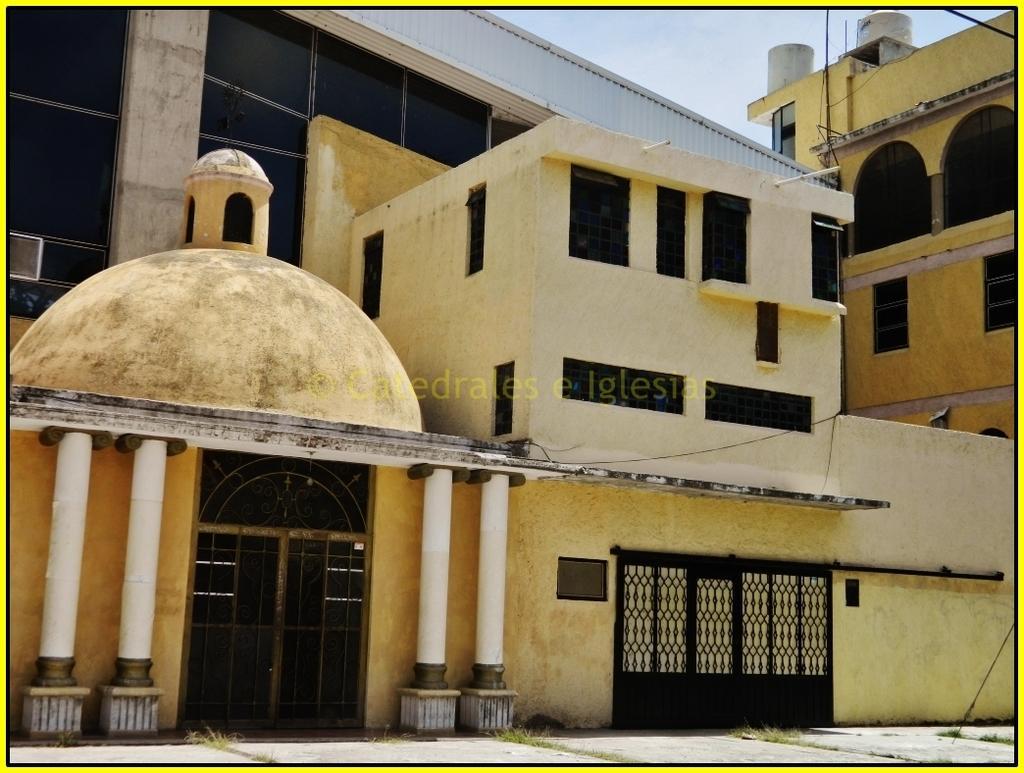How would you summarize this image in a sentence or two? This image consists of a building. It has a gate. It has windows and doors. There is sky at the top. 